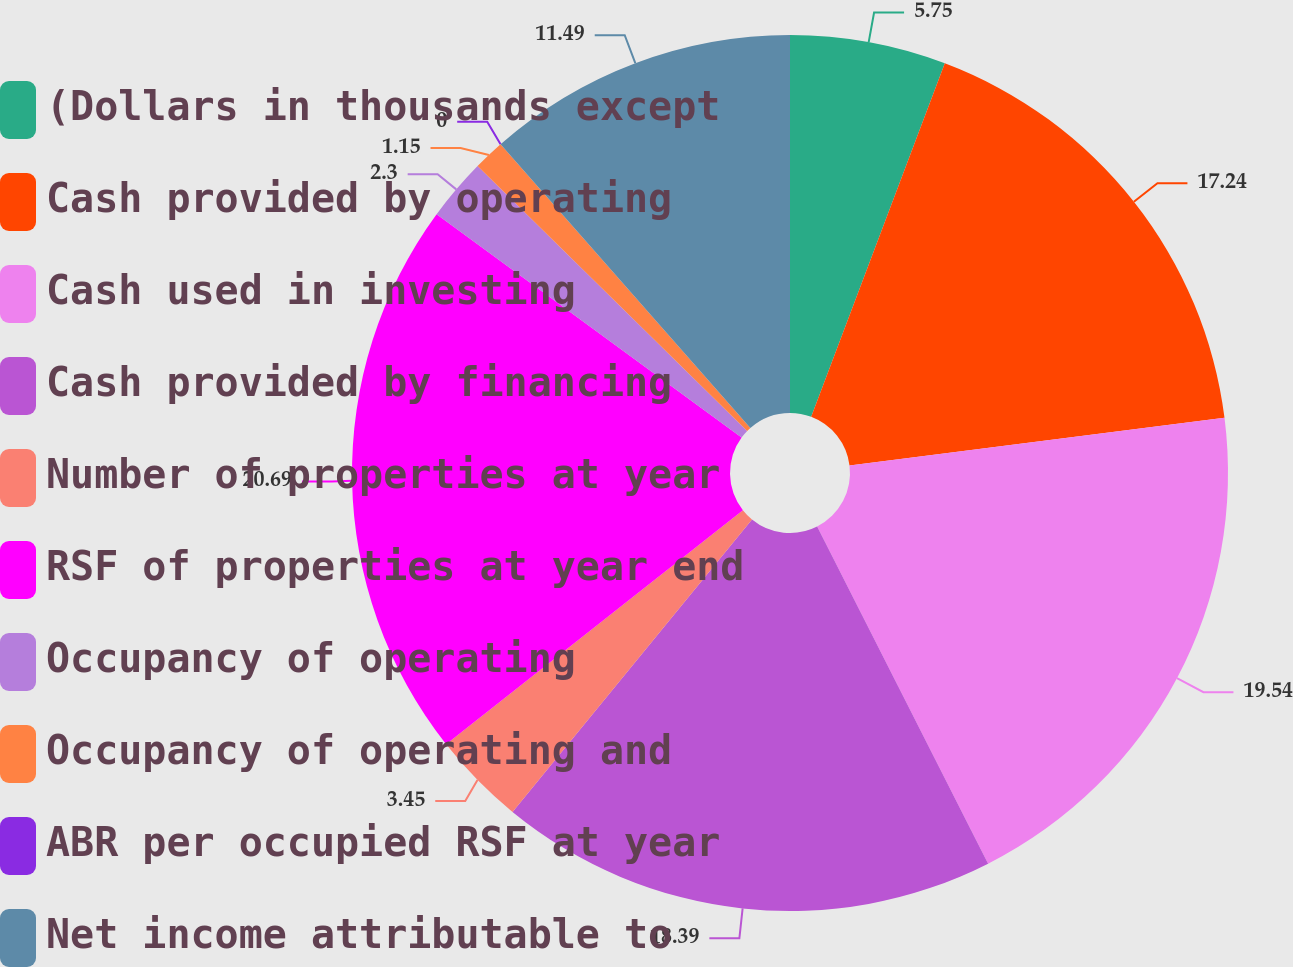Convert chart. <chart><loc_0><loc_0><loc_500><loc_500><pie_chart><fcel>(Dollars in thousands except<fcel>Cash provided by operating<fcel>Cash used in investing<fcel>Cash provided by financing<fcel>Number of properties at year<fcel>RSF of properties at year end<fcel>Occupancy of operating<fcel>Occupancy of operating and<fcel>ABR per occupied RSF at year<fcel>Net income attributable to<nl><fcel>5.75%<fcel>17.24%<fcel>19.54%<fcel>18.39%<fcel>3.45%<fcel>20.69%<fcel>2.3%<fcel>1.15%<fcel>0.0%<fcel>11.49%<nl></chart> 